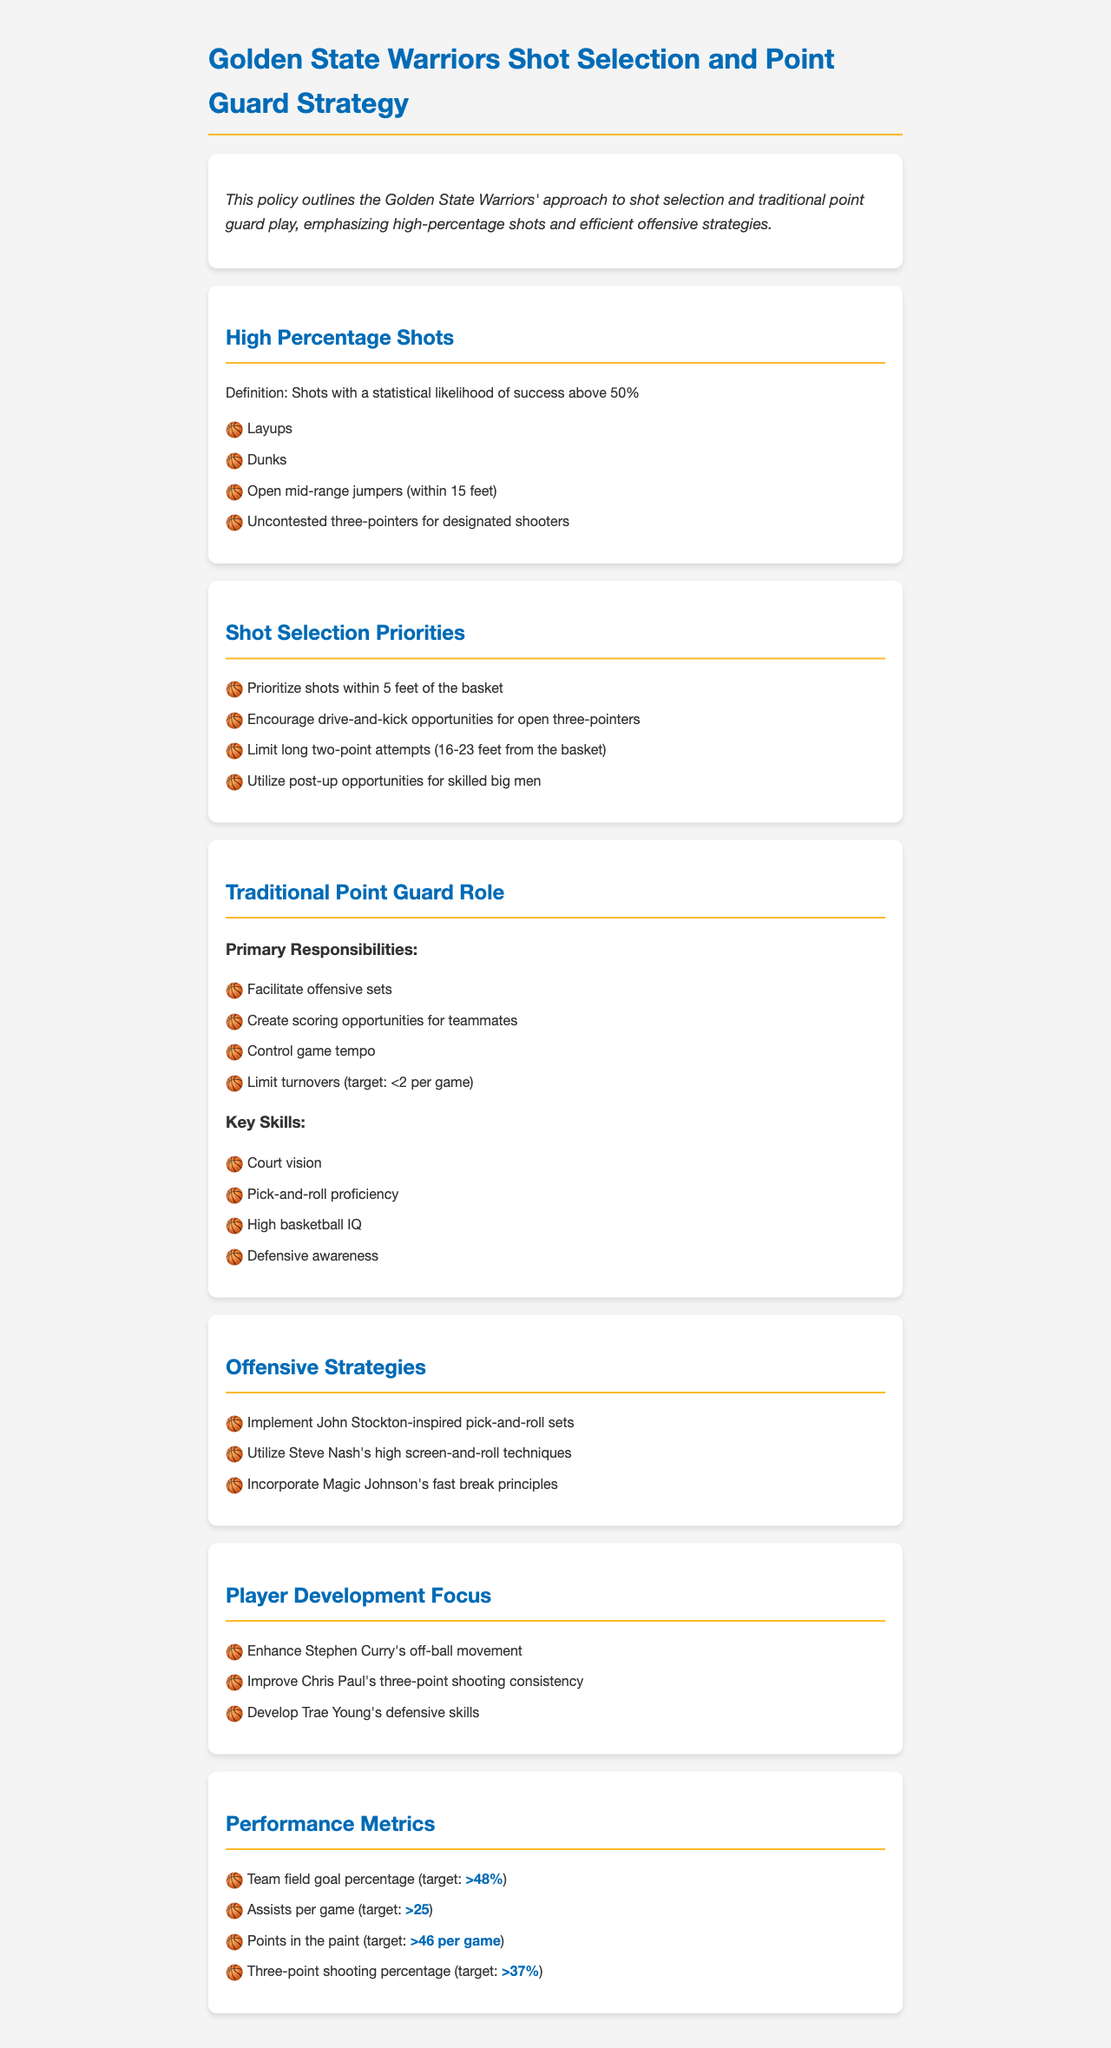What is the target team field goal percentage? The target team field goal percentage is specified in the document as above 48%.
Answer: >48% What type of shots are prioritized within 5 feet of the basket? The document lists shot types that are prioritized within 5 feet of the basket.
Answer: Layups, Dunks What is a primary responsibility of a traditional point guard? The document outlines several primary responsibilities, one of which must be identified.
Answer: Facilitate offensive sets What skills are highlighted for a traditional point guard? The document lists specific skills required for traditional point guards.
Answer: Court vision What offensive strategy is inspired by John Stockton? The document refers to a specific offensive strategy that is John Stockton-inspired.
Answer: Pick-and-roll sets What is the target for assists per game? The document specifies a numerical target for assists per game.
Answer: >25 Which player is mentioned for off-ball movement development? The document identifies a specific player for this developmental focus.
Answer: Stephen Curry What type of three-point shooting is being developed for Chris Paul? The document mentions an aspect of skill development for Chris Paul.
Answer: Consistency What is a high-percentage shot according to the document? The document defines high-percentage shots, and a well-known example can be given.
Answer: Layups 